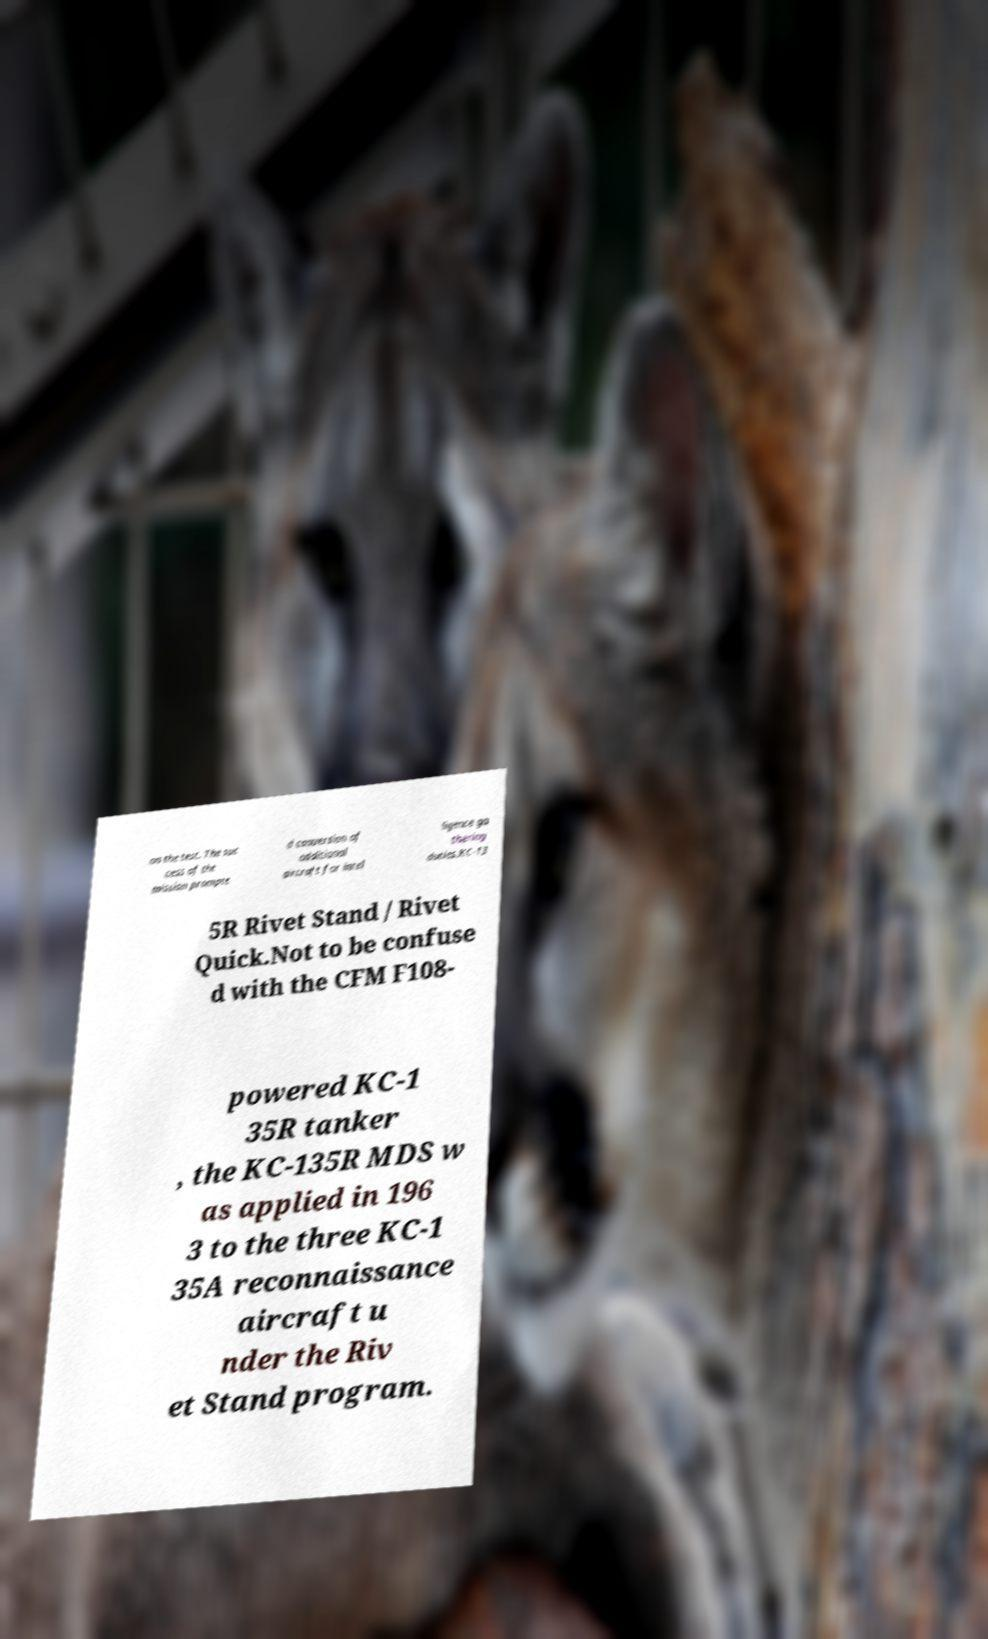I need the written content from this picture converted into text. Can you do that? on the test. The suc cess of the mission prompte d conversion of additional aircraft for intel ligence ga thering duties.KC-13 5R Rivet Stand / Rivet Quick.Not to be confuse d with the CFM F108- powered KC-1 35R tanker , the KC-135R MDS w as applied in 196 3 to the three KC-1 35A reconnaissance aircraft u nder the Riv et Stand program. 